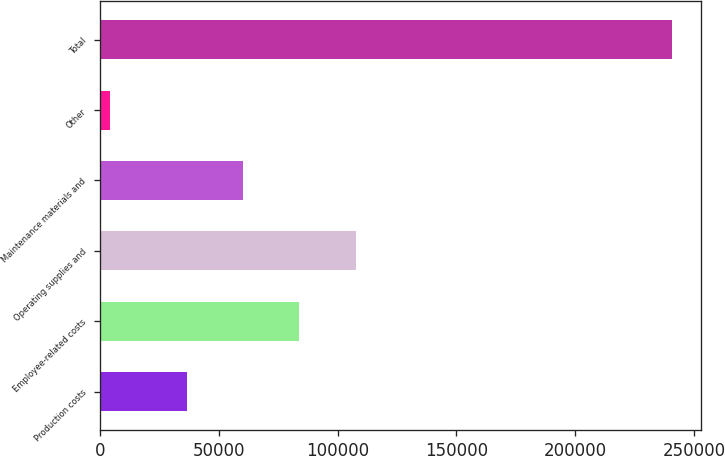Convert chart to OTSL. <chart><loc_0><loc_0><loc_500><loc_500><bar_chart><fcel>Production costs<fcel>Employee-related costs<fcel>Operating supplies and<fcel>Maintenance materials and<fcel>Other<fcel>Total<nl><fcel>36753<fcel>83980.8<fcel>107595<fcel>60366.9<fcel>4471<fcel>240610<nl></chart> 